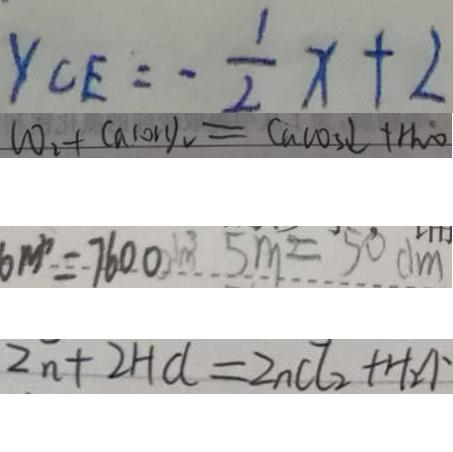Convert formula to latex. <formula><loc_0><loc_0><loc_500><loc_500>y _ { C E } = - \frac { 1 } { 2 } x + 2 
 C O _ { 2 } + C a ( O H ) _ { 2 } = C a C O _ { 3 } \downarrow + H _ { 2 } O 
 6 m ^ { 3 } = 7 6 0 0 m ^ { 3 } 5 m = 5 0 d m 
 Z n + 2 H C l = Z n C l _ { 2 } + H _ { 2 } \uparrow</formula> 